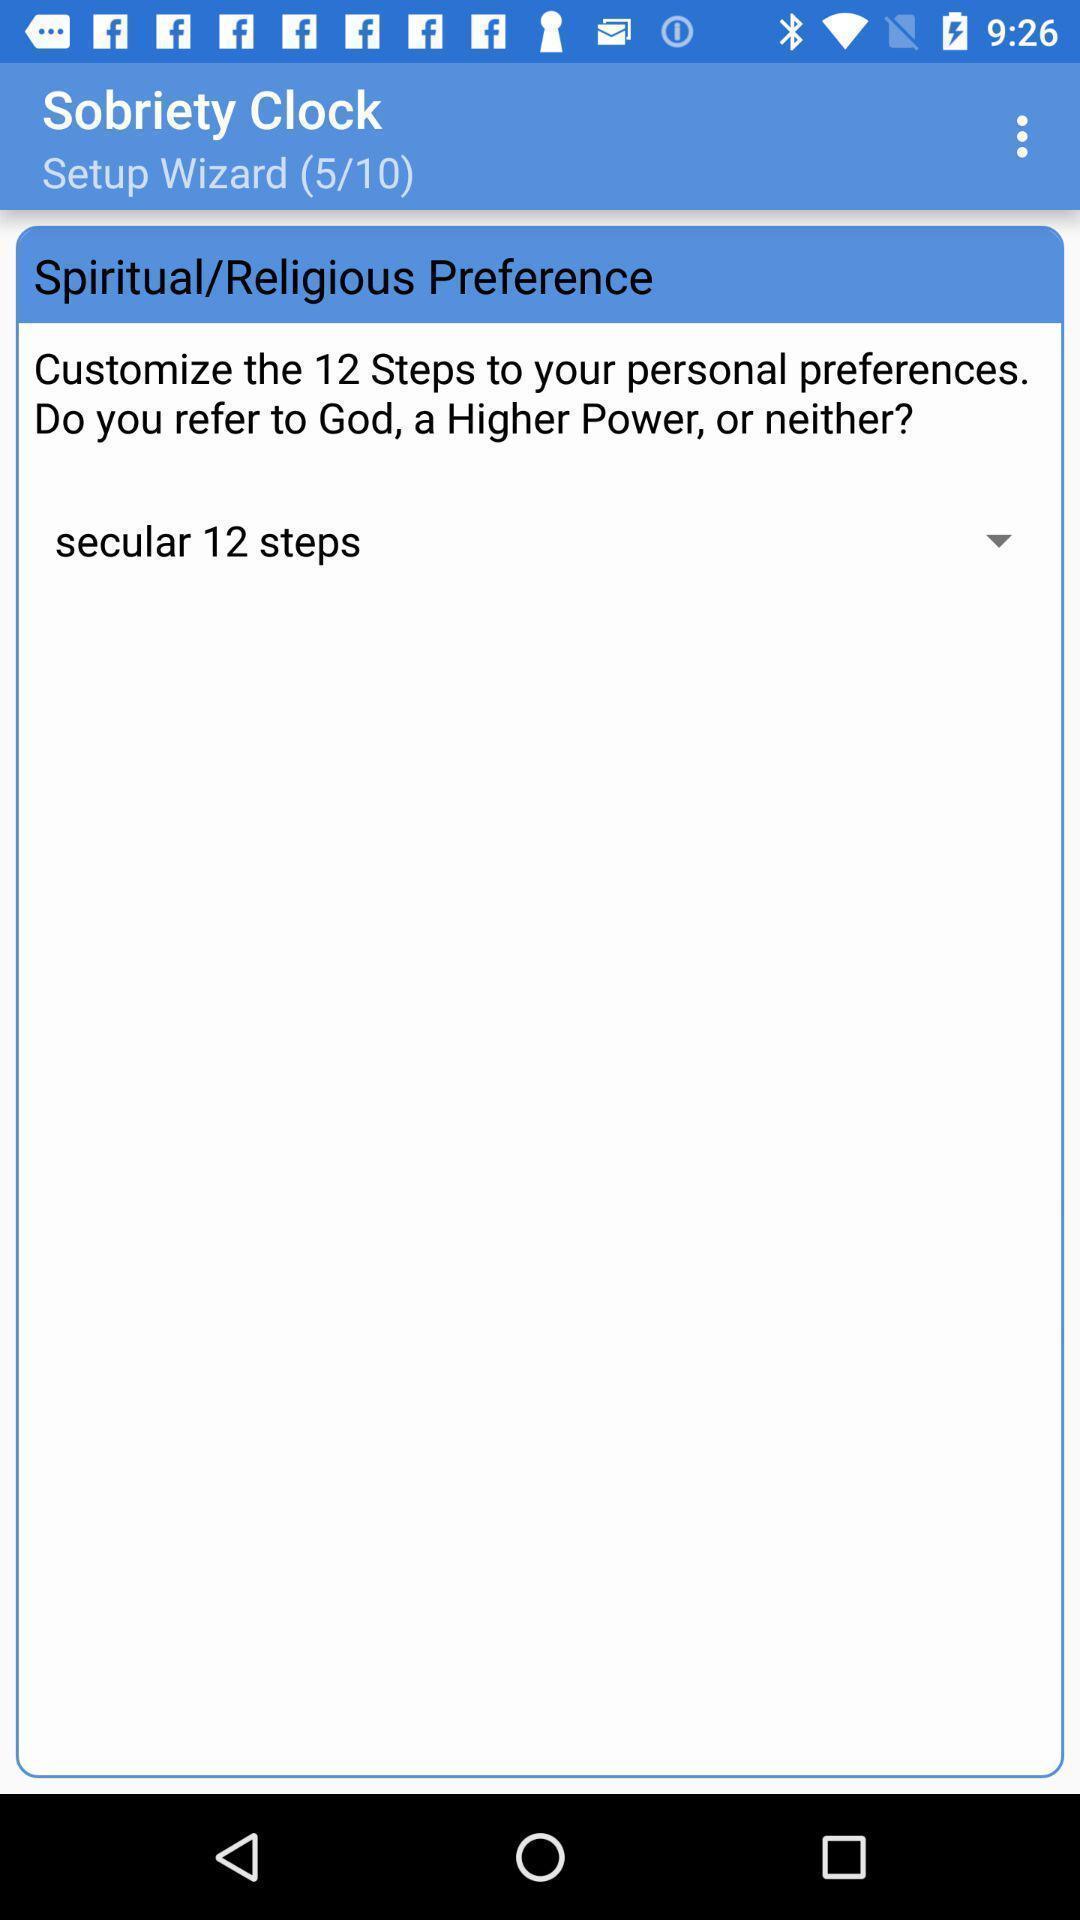What can you discern from this picture? Page displaying some text about sobriety. 